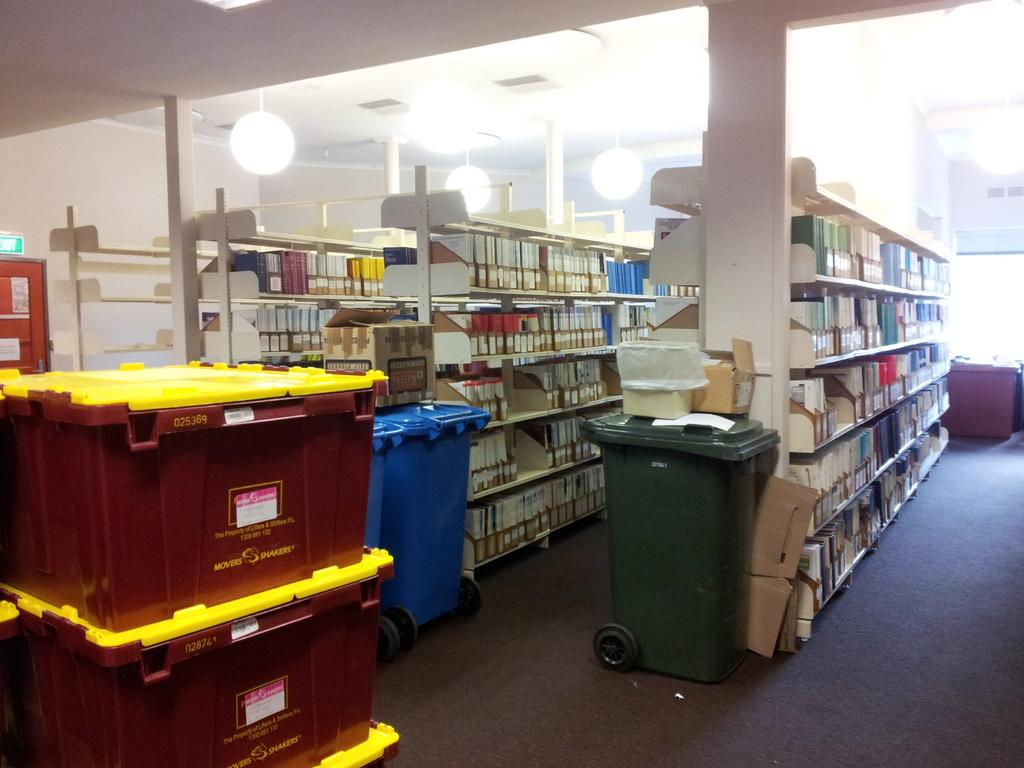Provide a one-sentence caption for the provided image. Red, hard-sided boxes with yellow lids made by Movers Shakers were stacked and waiting to be unloaded and replenish the shelves. 